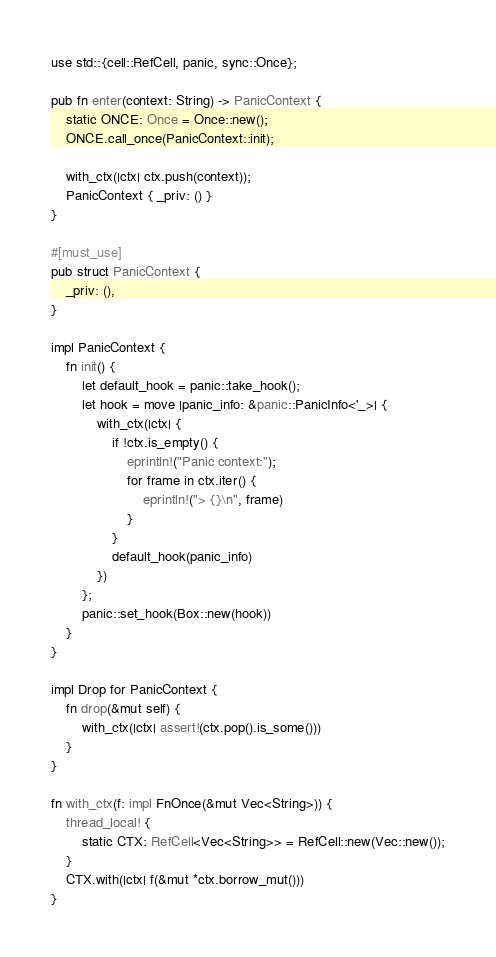<code> <loc_0><loc_0><loc_500><loc_500><_Rust_>
use std::{cell::RefCell, panic, sync::Once};

pub fn enter(context: String) -> PanicContext {
    static ONCE: Once = Once::new();
    ONCE.call_once(PanicContext::init);

    with_ctx(|ctx| ctx.push(context));
    PanicContext { _priv: () }
}

#[must_use]
pub struct PanicContext {
    _priv: (),
}

impl PanicContext {
    fn init() {
        let default_hook = panic::take_hook();
        let hook = move |panic_info: &panic::PanicInfo<'_>| {
            with_ctx(|ctx| {
                if !ctx.is_empty() {
                    eprintln!("Panic context:");
                    for frame in ctx.iter() {
                        eprintln!("> {}\n", frame)
                    }
                }
                default_hook(panic_info)
            })
        };
        panic::set_hook(Box::new(hook))
    }
}

impl Drop for PanicContext {
    fn drop(&mut self) {
        with_ctx(|ctx| assert!(ctx.pop().is_some()))
    }
}

fn with_ctx(f: impl FnOnce(&mut Vec<String>)) {
    thread_local! {
        static CTX: RefCell<Vec<String>> = RefCell::new(Vec::new());
    }
    CTX.with(|ctx| f(&mut *ctx.borrow_mut()))
}
</code> 